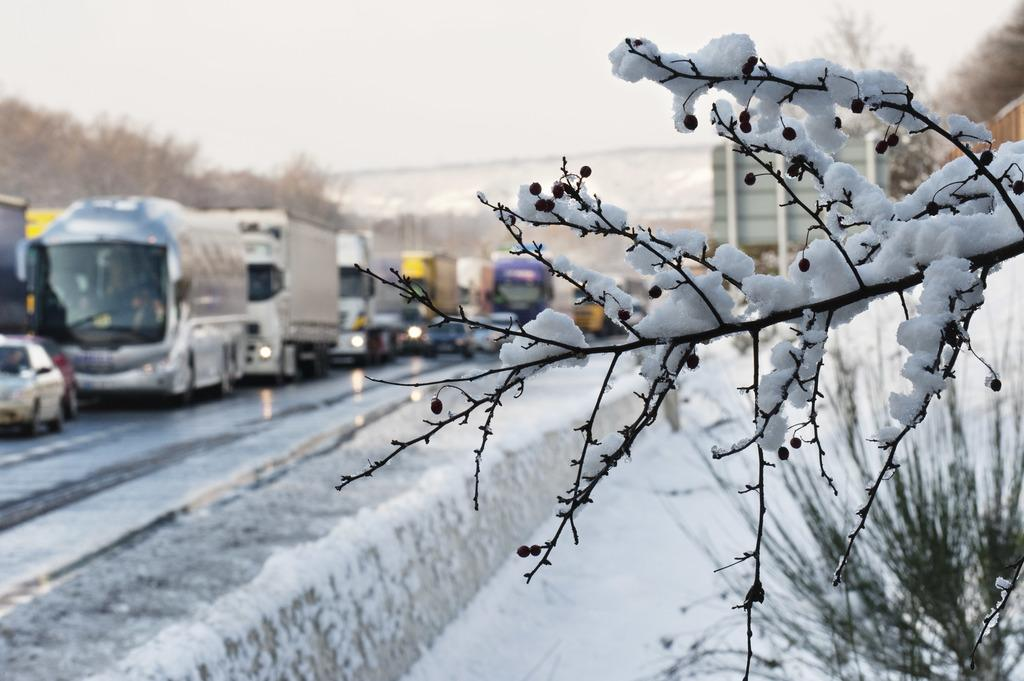What is located in the foreground of the image? There is a tree in the foreground of the image. What is covering the tree in the image? There is snow on the tree. What can be seen in the background of the image? There is snow, a plant, vehicles, trees, and buildings in the background of the image. How many cats can be seen climbing the tree in the image? There are no cats present in the image; it features a tree covered in snow. What type of nail is being used to secure the drain in the image? There is no drain or nail present in the image; it features a tree covered in snow and various elements in the background. 